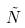<formula> <loc_0><loc_0><loc_500><loc_500>\tilde { N }</formula> 